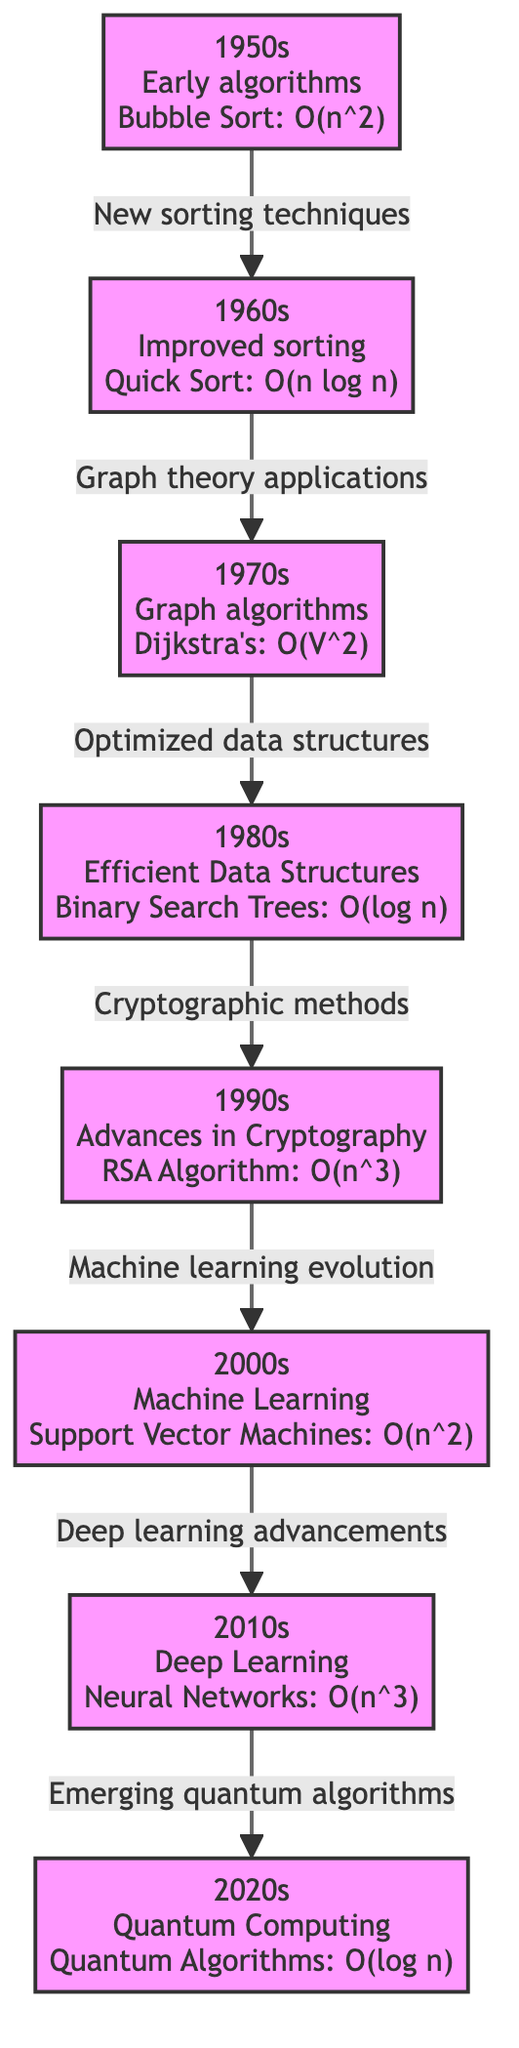What algorithm is associated with the 1960s? The diagram indicates that the algorithm associated with the 1960s is Quick Sort, characterized by a time complexity of O(n log n).
Answer: Quick Sort Which decade introduced Binary Search Trees? The diagram shows that Binary Search Trees were introduced in the 1980s, as indicated in the corresponding node.
Answer: 1980s What is the time complexity of Dijkstra's algorithm? The node for the 1970s states that Dijkstra's algorithm has a time complexity of O(V^2), which is key information regarding its efficiency.
Answer: O(V^2) How many decades are represented in the diagram? By counting the nodes from the 1950s to the 2020s, the diagram presents a total of eight decades.
Answer: Eight Which algorithm from the 2010s has the highest time complexity? According to the diagram, Neural Networks, associated with the 2010s, have a time complexity of O(n^3), which is higher than other listed algorithms from the same decade.
Answer: Neural Networks What connection exists between the 1990s and 2000s? The diagram illustrates a connection labeled "Machine learning evolution" that links the algorithm advancements in the 1990s to the developments in the 2000s.
Answer: Machine learning evolution In what decade did Quantum Algorithms emerge? The 2020s node clearly identifies the emergence of Quantum Algorithms as the new algorithms associated with this decade.
Answer: 2020s Which sorting technique was the primary focus in the 1950s? The diagram specifies that the primary sorting technique introduced in the 1950s was Bubble Sort, emphasizing its significance as an early algorithm.
Answer: Bubble Sort What was the significant advancement in algorithms during the 2000s? The diagram indicates that Support Vector Machines mark a significant advancement in algorithms during the 2000s, emphasizing the impact of machine learning.
Answer: Support Vector Machines 